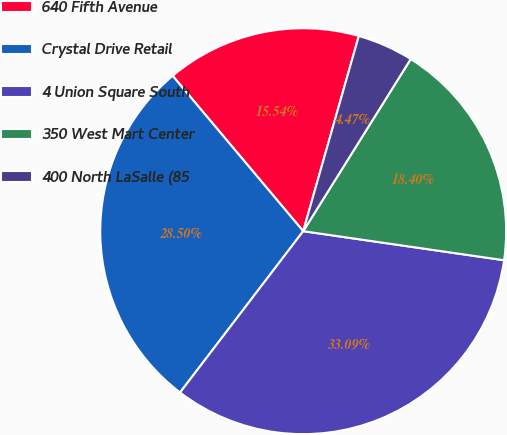Convert chart. <chart><loc_0><loc_0><loc_500><loc_500><pie_chart><fcel>640 Fifth Avenue<fcel>Crystal Drive Retail<fcel>4 Union Square South<fcel>350 West Mart Center<fcel>400 North LaSalle (85<nl><fcel>15.54%<fcel>28.5%<fcel>33.09%<fcel>18.4%<fcel>4.47%<nl></chart> 